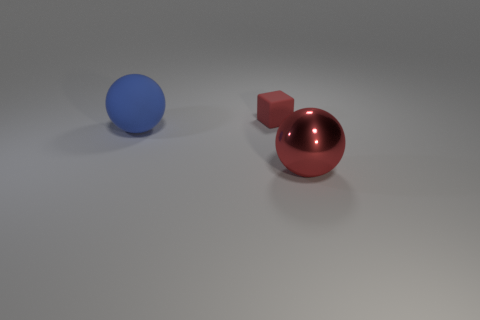Add 2 large shiny spheres. How many objects exist? 5 Subtract all spheres. How many objects are left? 1 Subtract 0 gray blocks. How many objects are left? 3 Subtract all tiny red matte blocks. Subtract all tiny purple shiny balls. How many objects are left? 2 Add 2 red shiny spheres. How many red shiny spheres are left? 3 Add 2 big matte spheres. How many big matte spheres exist? 3 